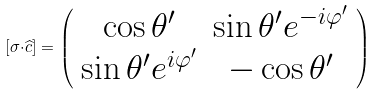<formula> <loc_0><loc_0><loc_500><loc_500>[ { \sigma \cdot } \widehat { c } ] = \left ( \begin{array} { c c } \cos \theta ^ { \prime } & \sin \theta ^ { \prime } e ^ { - i \varphi ^ { \prime } } \\ \sin \theta ^ { \prime } e ^ { i \varphi ^ { \prime } } & - \cos \theta ^ { \prime } \end{array} \right )</formula> 